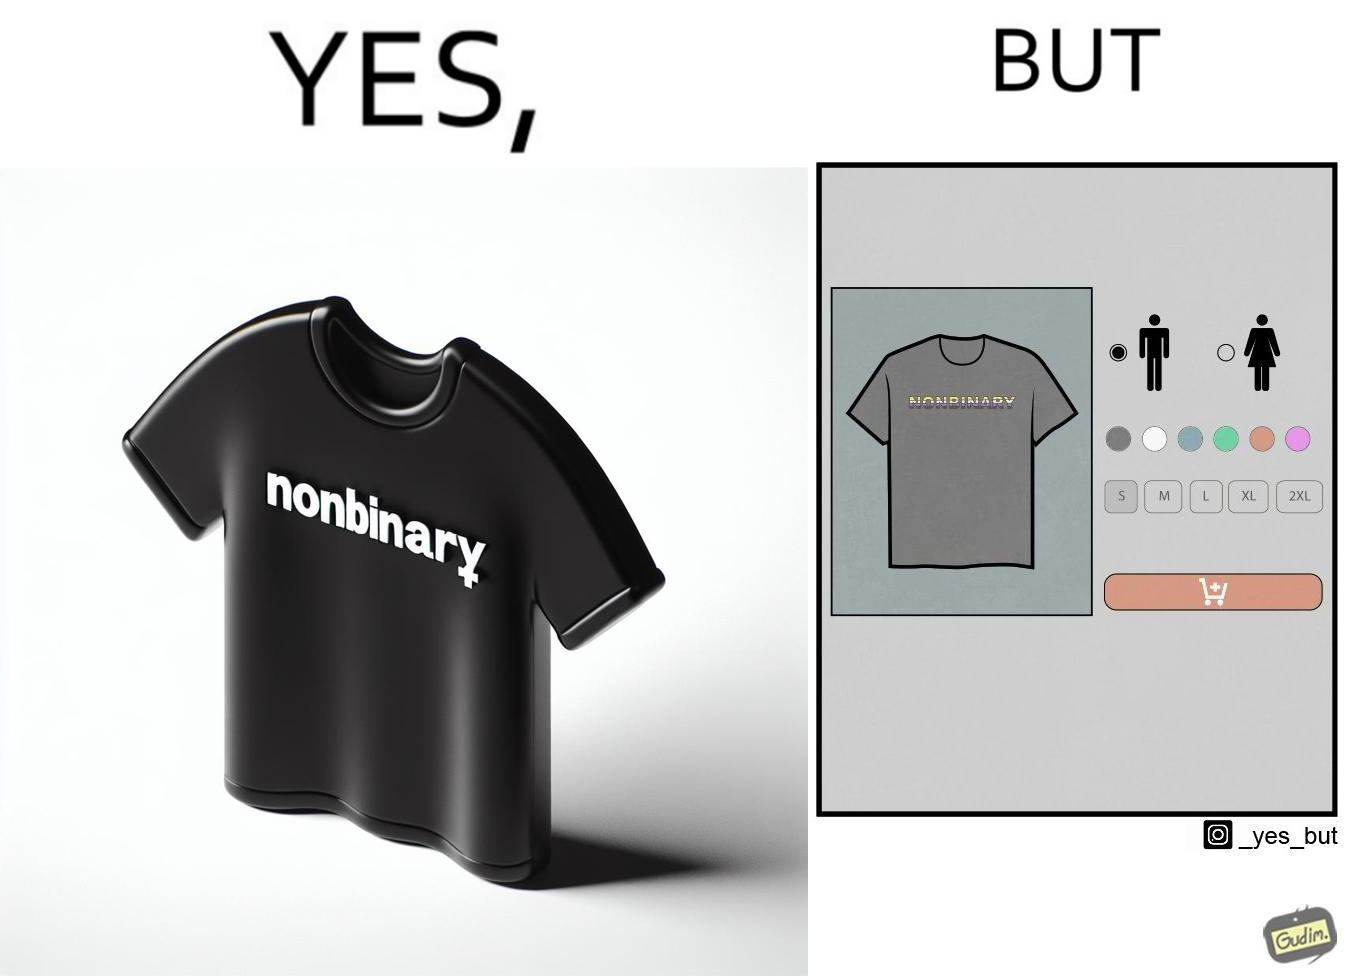Is this image satirical or non-satirical? Yes, this image is satirical. 